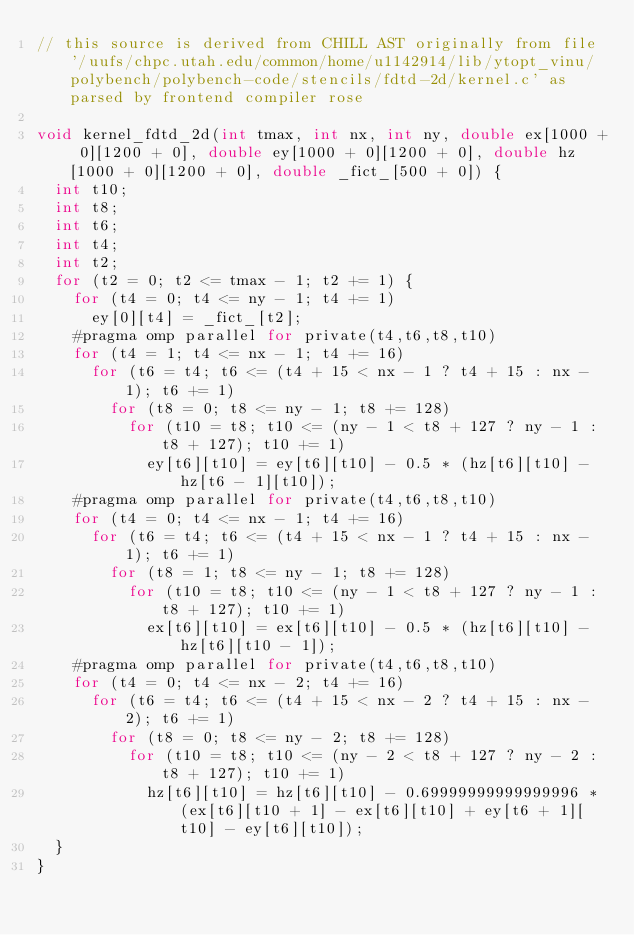Convert code to text. <code><loc_0><loc_0><loc_500><loc_500><_C_>// this source is derived from CHILL AST originally from file '/uufs/chpc.utah.edu/common/home/u1142914/lib/ytopt_vinu/polybench/polybench-code/stencils/fdtd-2d/kernel.c' as parsed by frontend compiler rose

void kernel_fdtd_2d(int tmax, int nx, int ny, double ex[1000 + 0][1200 + 0], double ey[1000 + 0][1200 + 0], double hz[1000 + 0][1200 + 0], double _fict_[500 + 0]) {
  int t10;
  int t8;
  int t6;
  int t4;
  int t2;
  for (t2 = 0; t2 <= tmax - 1; t2 += 1) {
    for (t4 = 0; t4 <= ny - 1; t4 += 1) 
      ey[0][t4] = _fict_[t2];
    #pragma omp parallel for private(t4,t6,t8,t10)
    for (t4 = 1; t4 <= nx - 1; t4 += 16) 
      for (t6 = t4; t6 <= (t4 + 15 < nx - 1 ? t4 + 15 : nx - 1); t6 += 1) 
        for (t8 = 0; t8 <= ny - 1; t8 += 128) 
          for (t10 = t8; t10 <= (ny - 1 < t8 + 127 ? ny - 1 : t8 + 127); t10 += 1) 
            ey[t6][t10] = ey[t6][t10] - 0.5 * (hz[t6][t10] - hz[t6 - 1][t10]);
    #pragma omp parallel for private(t4,t6,t8,t10)
    for (t4 = 0; t4 <= nx - 1; t4 += 16) 
      for (t6 = t4; t6 <= (t4 + 15 < nx - 1 ? t4 + 15 : nx - 1); t6 += 1) 
        for (t8 = 1; t8 <= ny - 1; t8 += 128) 
          for (t10 = t8; t10 <= (ny - 1 < t8 + 127 ? ny - 1 : t8 + 127); t10 += 1) 
            ex[t6][t10] = ex[t6][t10] - 0.5 * (hz[t6][t10] - hz[t6][t10 - 1]);
    #pragma omp parallel for private(t4,t6,t8,t10)
    for (t4 = 0; t4 <= nx - 2; t4 += 16) 
      for (t6 = t4; t6 <= (t4 + 15 < nx - 2 ? t4 + 15 : nx - 2); t6 += 1) 
        for (t8 = 0; t8 <= ny - 2; t8 += 128) 
          for (t10 = t8; t10 <= (ny - 2 < t8 + 127 ? ny - 2 : t8 + 127); t10 += 1) 
            hz[t6][t10] = hz[t6][t10] - 0.69999999999999996 * (ex[t6][t10 + 1] - ex[t6][t10] + ey[t6 + 1][t10] - ey[t6][t10]);
  }
}
</code> 